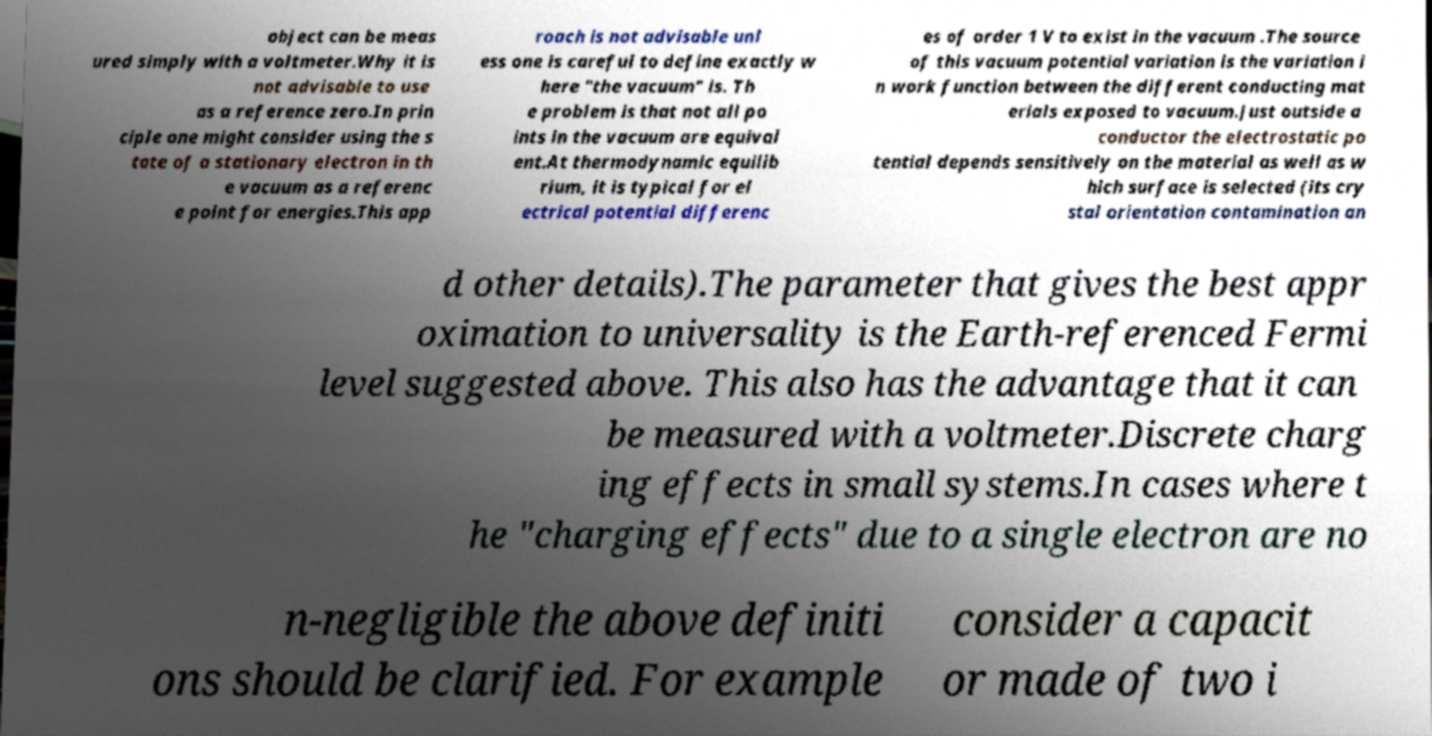For documentation purposes, I need the text within this image transcribed. Could you provide that? object can be meas ured simply with a voltmeter.Why it is not advisable to use as a reference zero.In prin ciple one might consider using the s tate of a stationary electron in th e vacuum as a referenc e point for energies.This app roach is not advisable unl ess one is careful to define exactly w here "the vacuum" is. Th e problem is that not all po ints in the vacuum are equival ent.At thermodynamic equilib rium, it is typical for el ectrical potential differenc es of order 1 V to exist in the vacuum .The source of this vacuum potential variation is the variation i n work function between the different conducting mat erials exposed to vacuum.Just outside a conductor the electrostatic po tential depends sensitively on the material as well as w hich surface is selected (its cry stal orientation contamination an d other details).The parameter that gives the best appr oximation to universality is the Earth-referenced Fermi level suggested above. This also has the advantage that it can be measured with a voltmeter.Discrete charg ing effects in small systems.In cases where t he "charging effects" due to a single electron are no n-negligible the above definiti ons should be clarified. For example consider a capacit or made of two i 